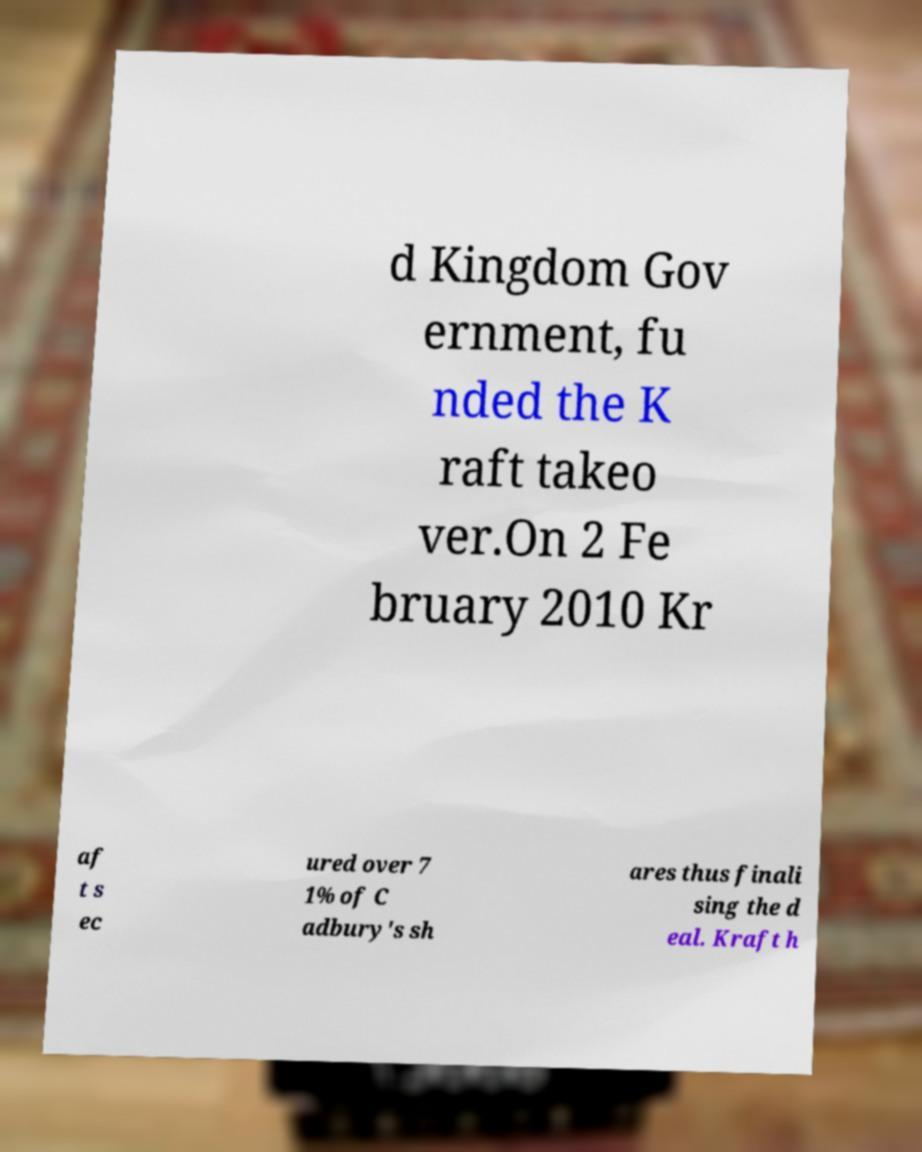Could you extract and type out the text from this image? d Kingdom Gov ernment, fu nded the K raft takeo ver.On 2 Fe bruary 2010 Kr af t s ec ured over 7 1% of C adbury's sh ares thus finali sing the d eal. Kraft h 